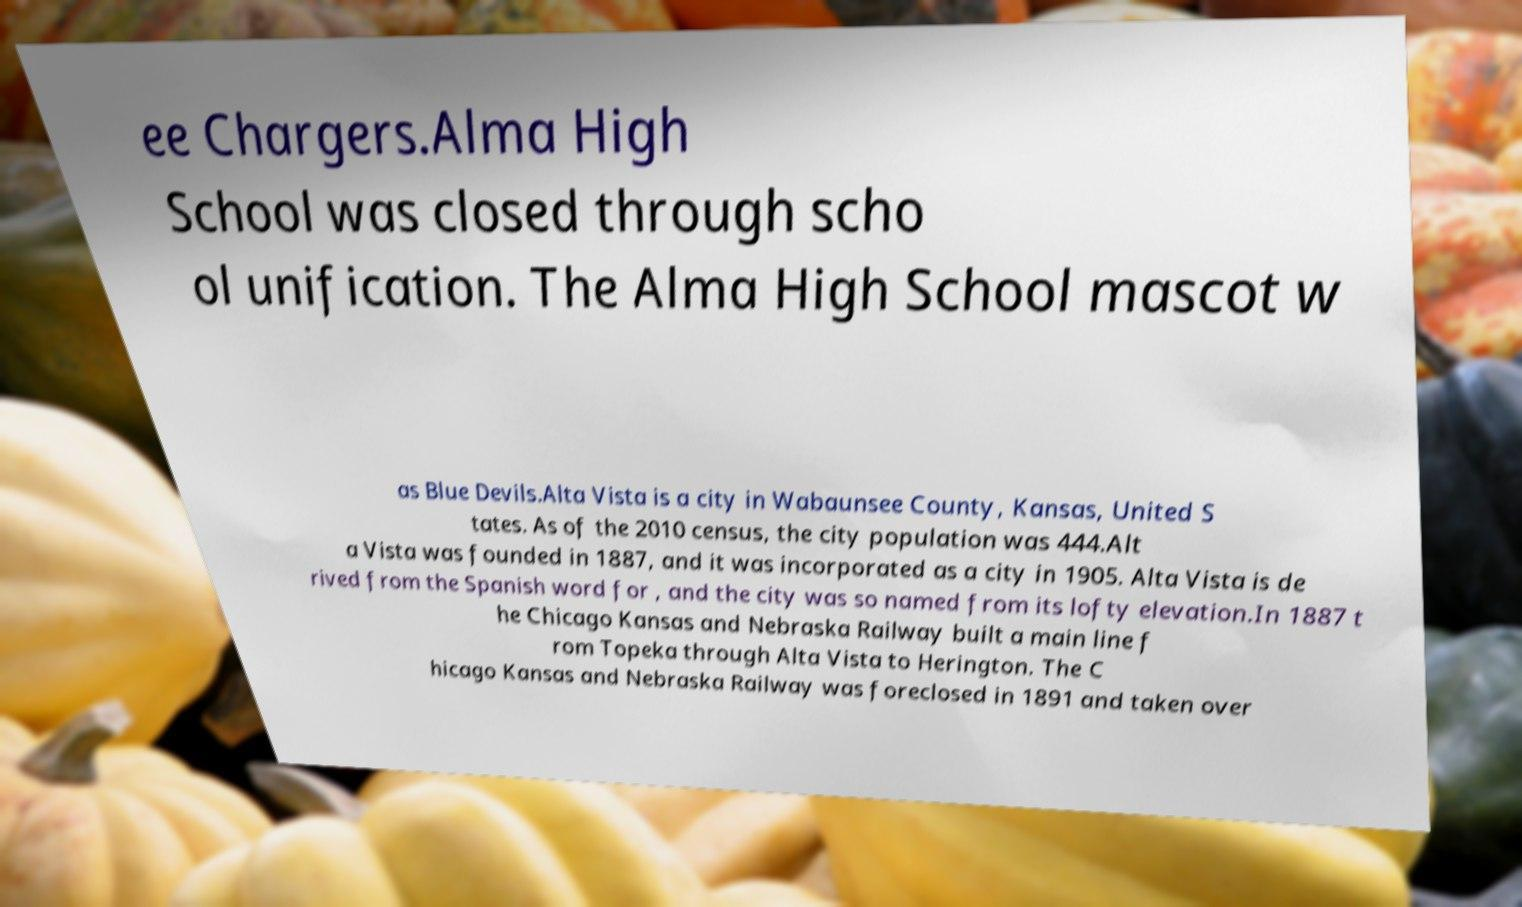Please read and relay the text visible in this image. What does it say? ee Chargers.Alma High School was closed through scho ol unification. The Alma High School mascot w as Blue Devils.Alta Vista is a city in Wabaunsee County, Kansas, United S tates. As of the 2010 census, the city population was 444.Alt a Vista was founded in 1887, and it was incorporated as a city in 1905. Alta Vista is de rived from the Spanish word for , and the city was so named from its lofty elevation.In 1887 t he Chicago Kansas and Nebraska Railway built a main line f rom Topeka through Alta Vista to Herington. The C hicago Kansas and Nebraska Railway was foreclosed in 1891 and taken over 